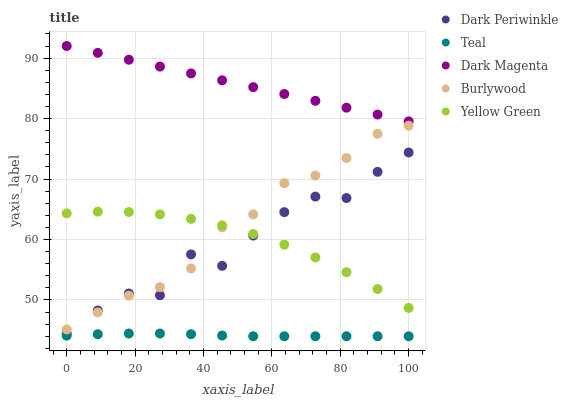Does Teal have the minimum area under the curve?
Answer yes or no. Yes. Does Dark Magenta have the maximum area under the curve?
Answer yes or no. Yes. Does Yellow Green have the minimum area under the curve?
Answer yes or no. No. Does Yellow Green have the maximum area under the curve?
Answer yes or no. No. Is Dark Magenta the smoothest?
Answer yes or no. Yes. Is Dark Periwinkle the roughest?
Answer yes or no. Yes. Is Yellow Green the smoothest?
Answer yes or no. No. Is Yellow Green the roughest?
Answer yes or no. No. Does Teal have the lowest value?
Answer yes or no. Yes. Does Yellow Green have the lowest value?
Answer yes or no. No. Does Dark Magenta have the highest value?
Answer yes or no. Yes. Does Yellow Green have the highest value?
Answer yes or no. No. Is Burlywood less than Dark Magenta?
Answer yes or no. Yes. Is Dark Magenta greater than Teal?
Answer yes or no. Yes. Does Yellow Green intersect Burlywood?
Answer yes or no. Yes. Is Yellow Green less than Burlywood?
Answer yes or no. No. Is Yellow Green greater than Burlywood?
Answer yes or no. No. Does Burlywood intersect Dark Magenta?
Answer yes or no. No. 